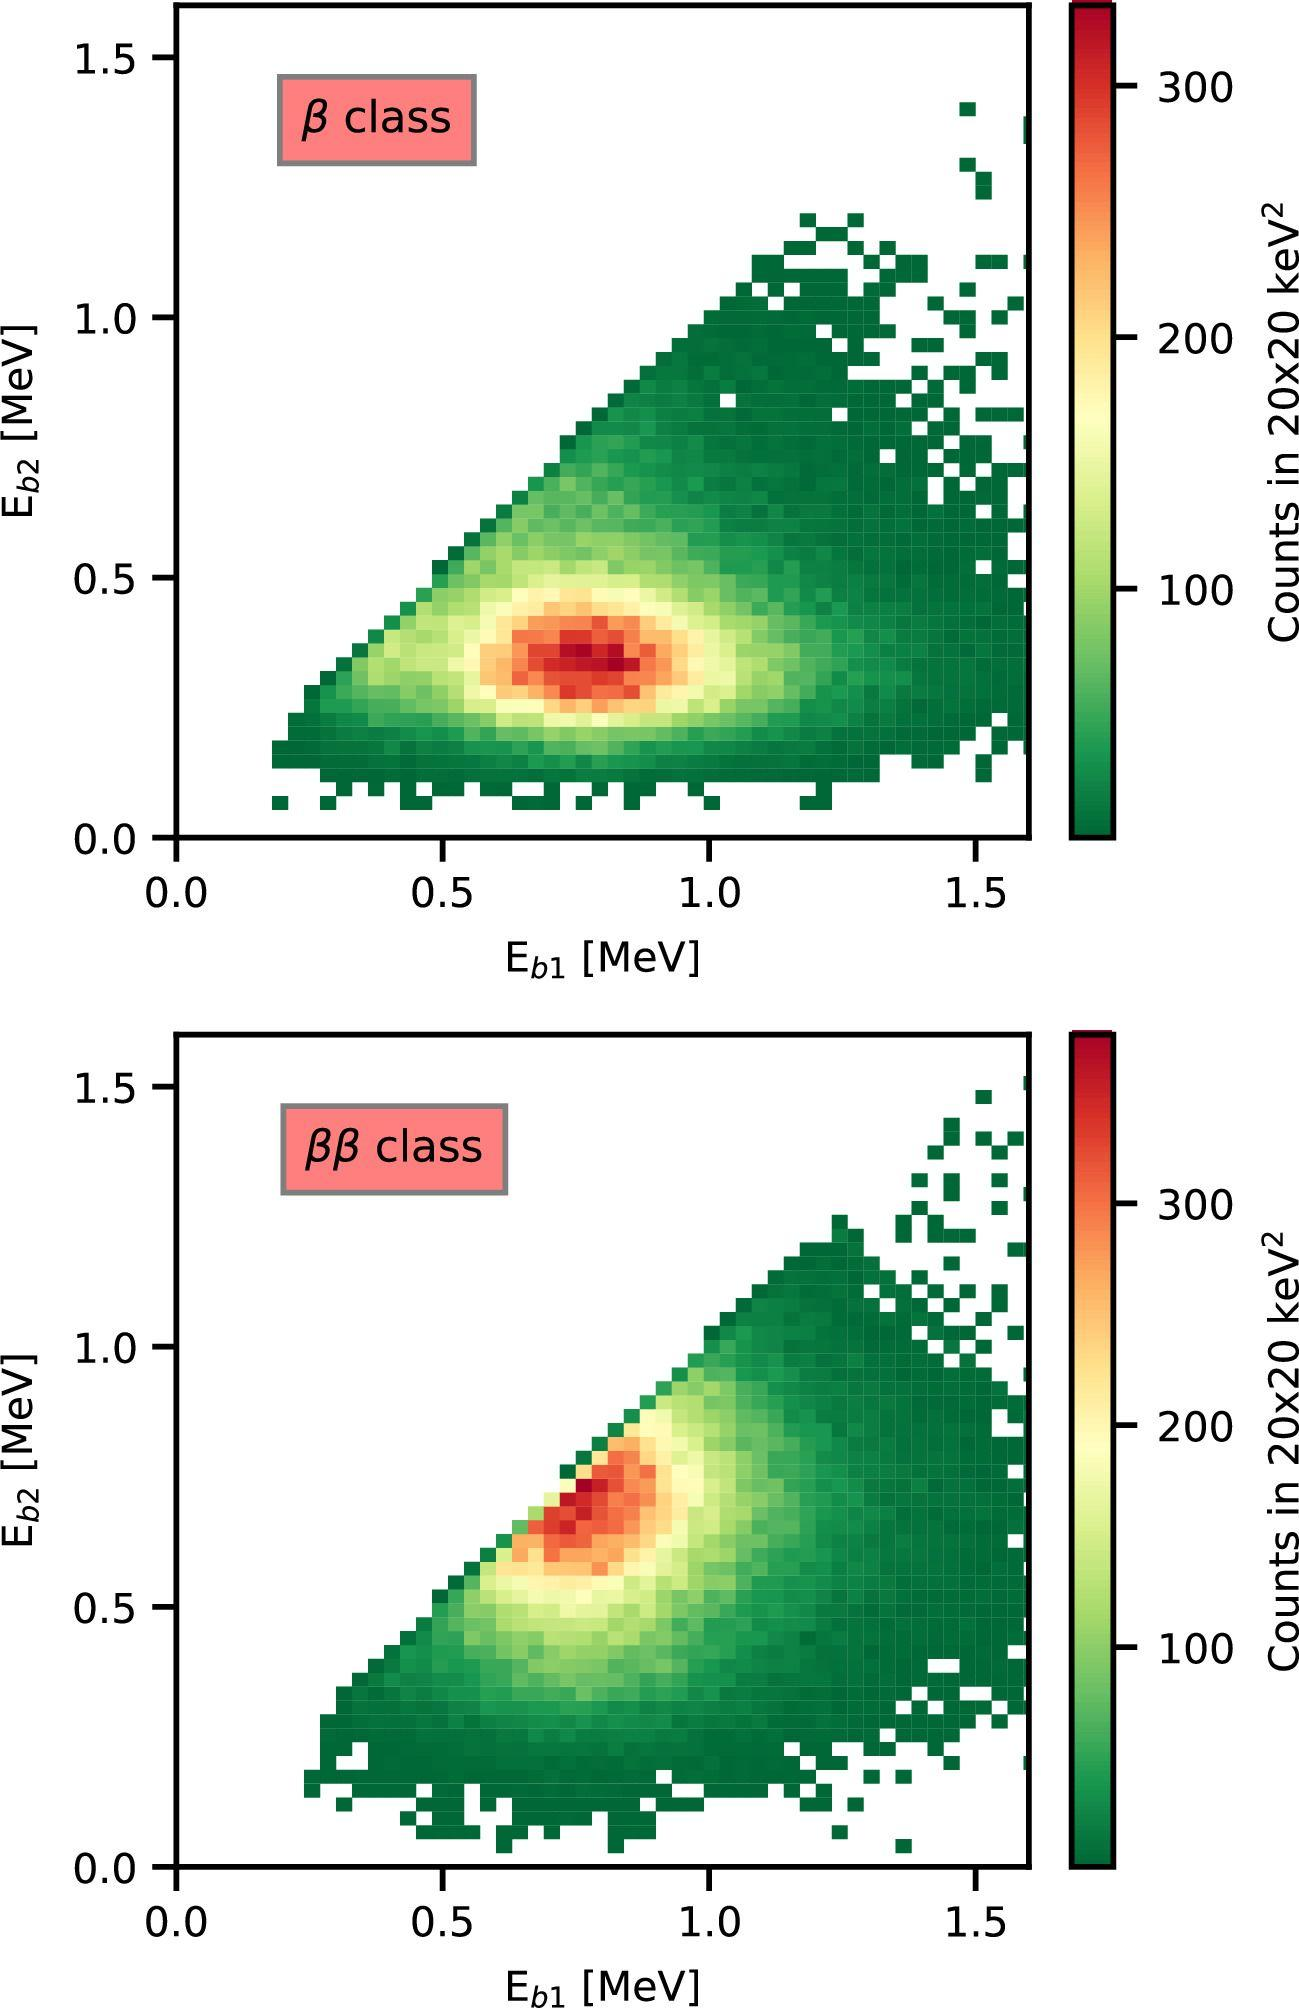Based on the color intensity in the figures, where is the highest concentration of data points found? A) In the lower left corner of each figure B) Along the diagonal from the lower left to upper right corner C) In the upper right corner of each figure D) Evenly distributed throughout each figure Upon examining the figures that plot the energy distributions labeled 'E_b1' versus 'E_b2', one can observe that the regions of highest data point density are manifested as the most intensely colored areas. These areas follow a distinct path from the lower left to the upper right corner in each plot, forming a pronounced diagonal. The scale at the right side, asserting 'Counts in 2020 keV^2,' serves as a legend, with the warmest colors representing higher concentrations of data points. Thus, the answer is B) Along the diagonal from the lower left to the upper right corner of each figure, which indicates a strong correlation between the two energies measured in the beta decay processes, likely characteristic of a particular reaction or decay channel in particle physics. 